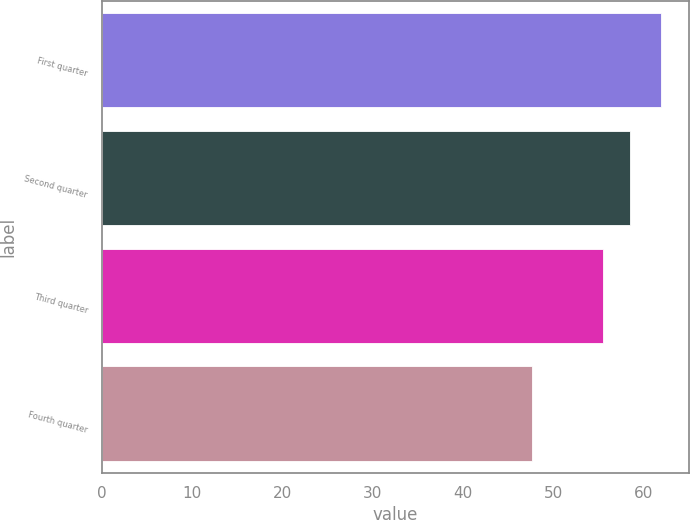Convert chart to OTSL. <chart><loc_0><loc_0><loc_500><loc_500><bar_chart><fcel>First quarter<fcel>Second quarter<fcel>Third quarter<fcel>Fourth quarter<nl><fcel>61.95<fcel>58.43<fcel>55.52<fcel>47.57<nl></chart> 